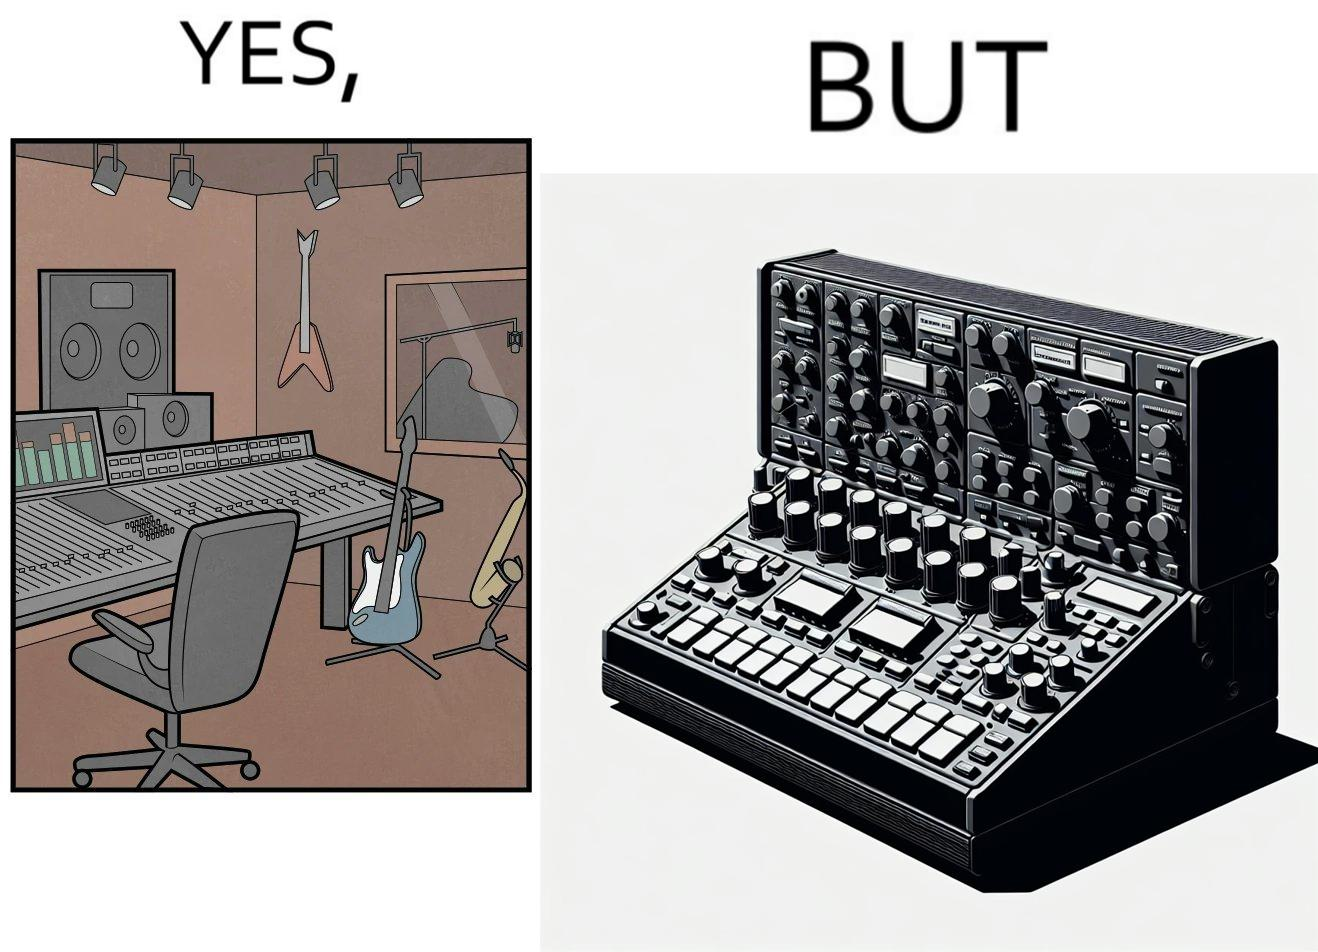What is shown in this image? The image overall is funny because even though people have great music studios and instruments to create and record music, they use electronic replacements of the musical instruments to achieve the task. 